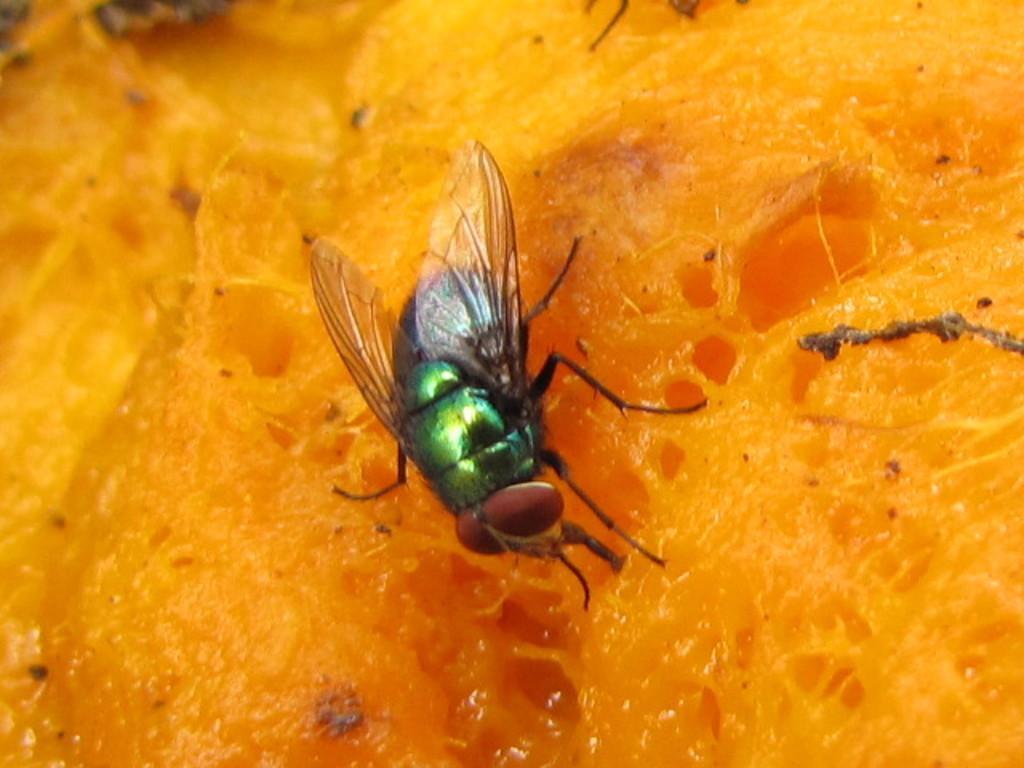Can you describe this image briefly? In this image we can see a fly. 